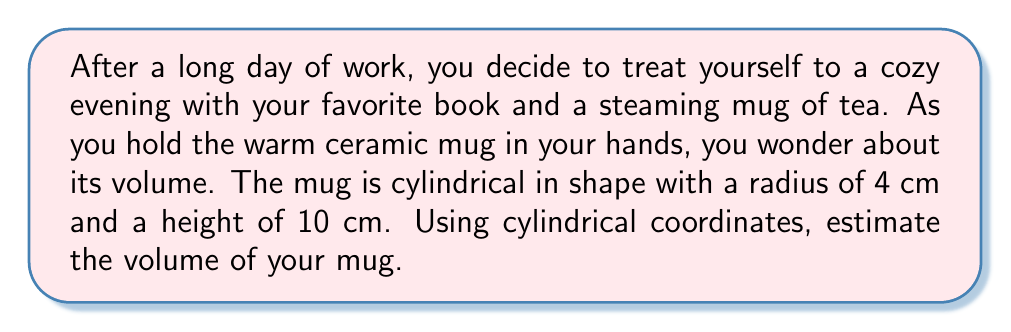Solve this math problem. To estimate the volume of the mug using cylindrical coordinates, we'll follow these steps:

1) In cylindrical coordinates, a point is represented by $(r, \theta, z)$, where:
   - $r$ is the distance from the point to the z-axis
   - $\theta$ is the angle in the xy-plane from the positive x-axis
   - $z$ is the height above the xy-plane

2) The volume formula in cylindrical coordinates is:

   $$V = \int_0^{2\pi} \int_0^R \int_0^H r \,dz\,dr\,d\theta$$

   Where $R$ is the radius of the base and $H$ is the height of the cylinder.

3) For our mug:
   $R = 4$ cm
   $H = 10$ cm

4) Let's substitute these values into our formula:

   $$V = \int_0^{2\pi} \int_0^4 \int_0^{10} r \,dz\,dr\,d\theta$$

5) Integrate with respect to $z$ first:

   $$V = \int_0^{2\pi} \int_0^4 [rz]_0^{10} \,dr\,d\theta = \int_0^{2\pi} \int_0^4 10r \,dr\,d\theta$$

6) Now integrate with respect to $r$:

   $$V = \int_0^{2\pi} [5r^2]_0^4 \,d\theta = \int_0^{2\pi} 80 \,d\theta$$

7) Finally, integrate with respect to $\theta$:

   $$V = [80\theta]_0^{2\pi} = 160\pi$$

8) Therefore, the volume of the mug is $160\pi$ cubic centimeters.
Answer: The volume of the mug is $160\pi$ cm³ or approximately 502.65 cm³. 